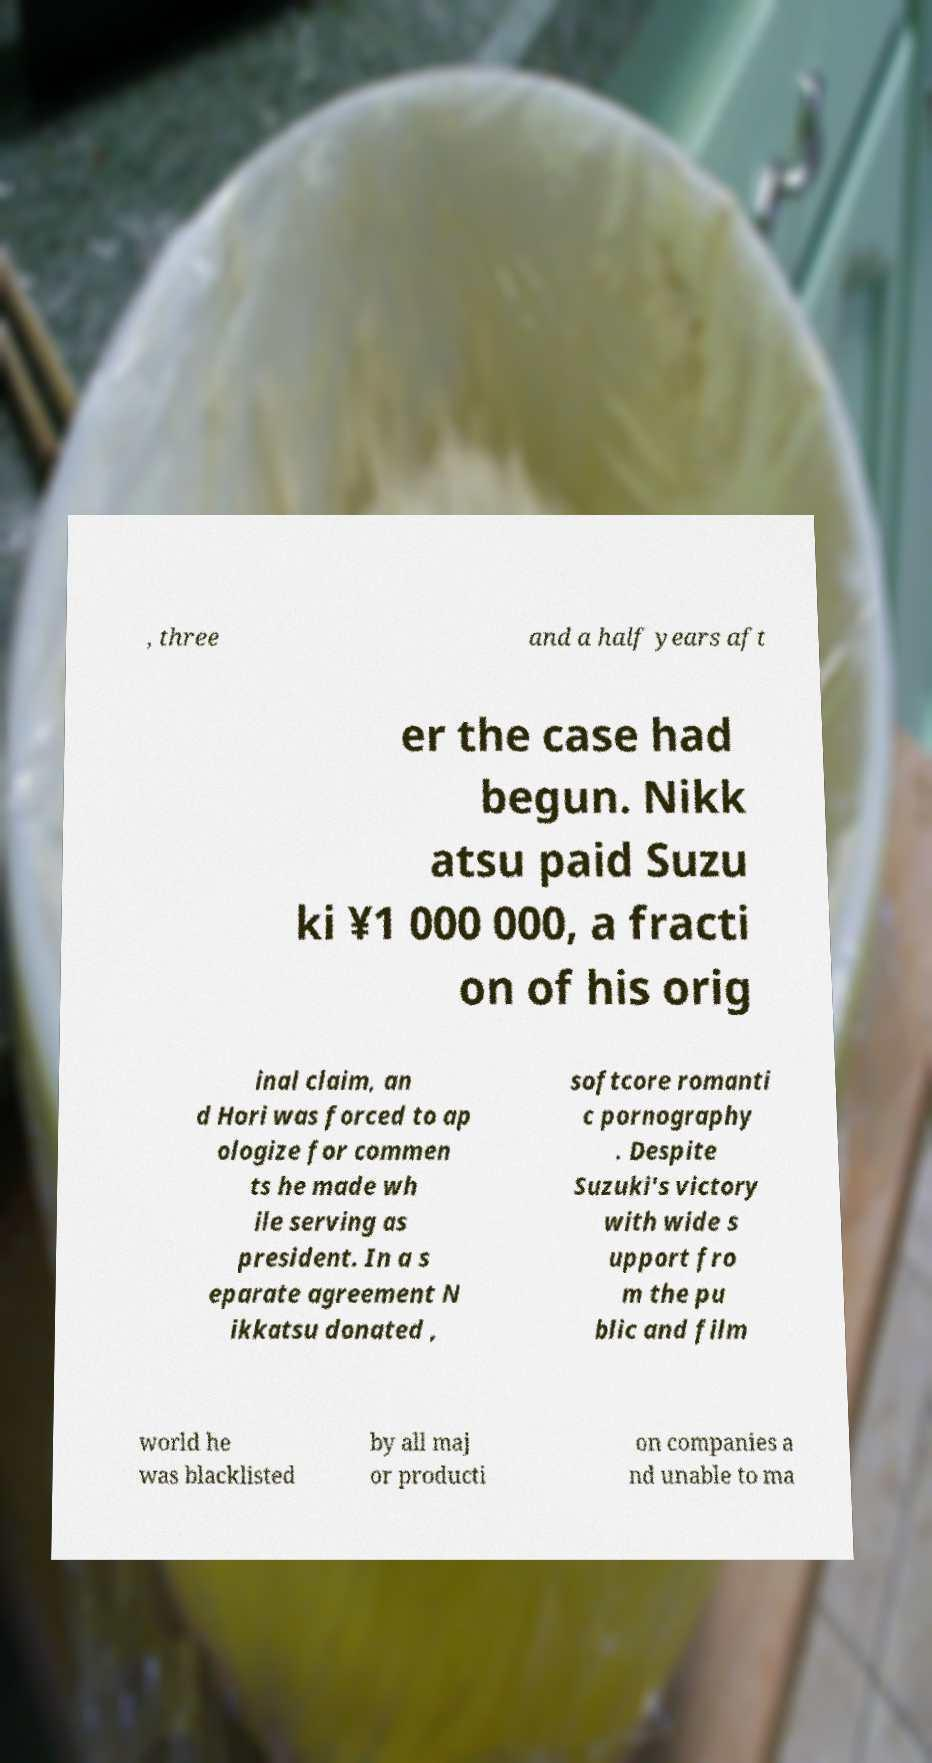Could you extract and type out the text from this image? , three and a half years aft er the case had begun. Nikk atsu paid Suzu ki ¥1 000 000, a fracti on of his orig inal claim, an d Hori was forced to ap ologize for commen ts he made wh ile serving as president. In a s eparate agreement N ikkatsu donated , softcore romanti c pornography . Despite Suzuki's victory with wide s upport fro m the pu blic and film world he was blacklisted by all maj or producti on companies a nd unable to ma 